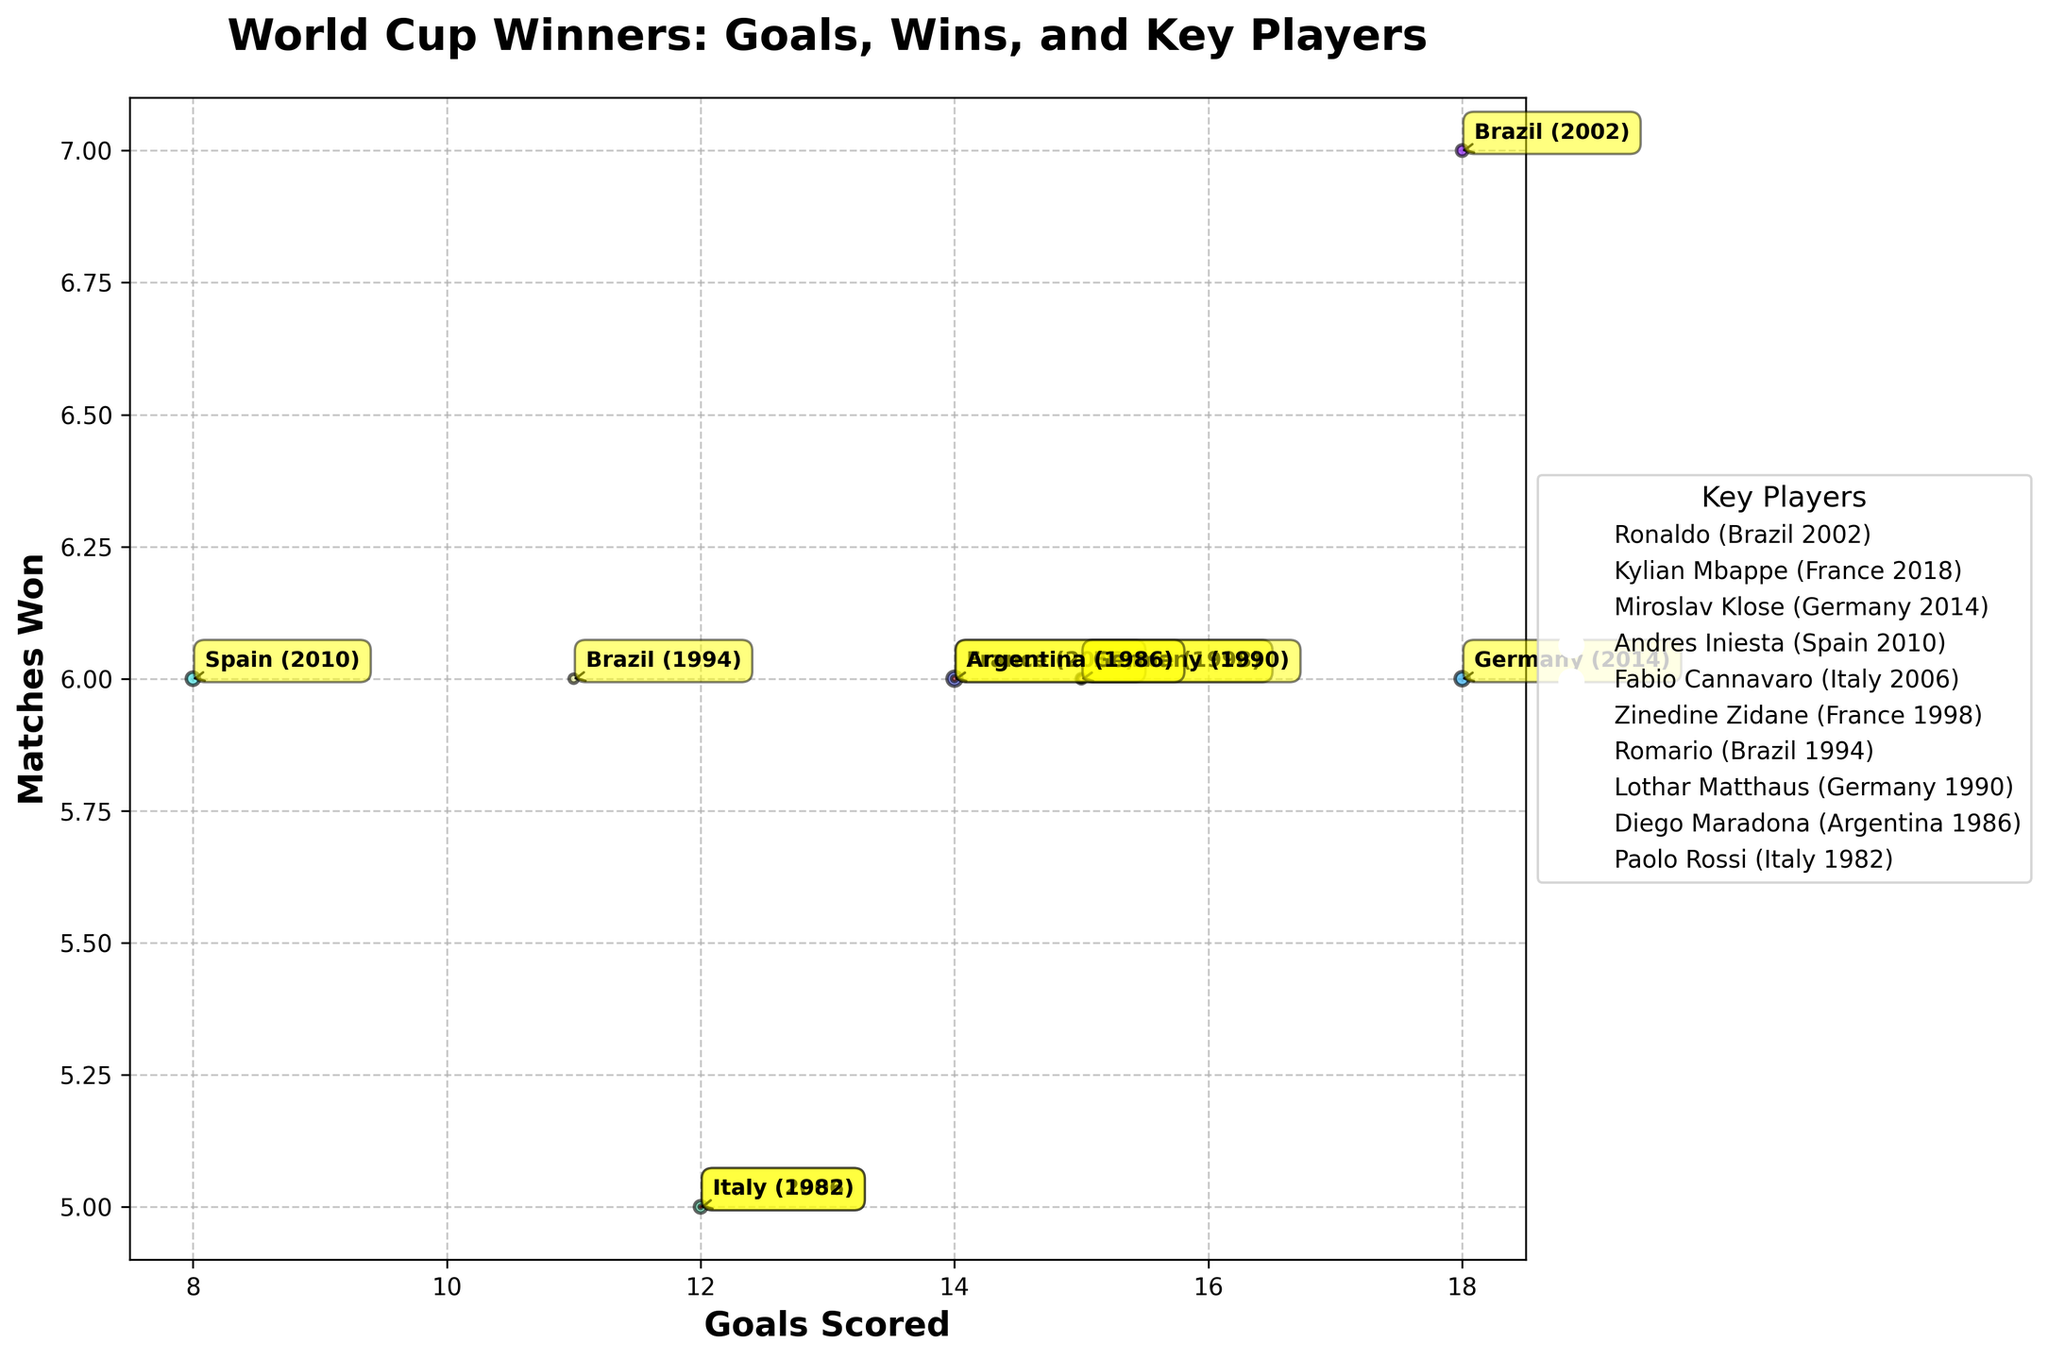What's the title of the figure? The title of the figure is positioned above the main bubble chart and provides context for what the chart represents.
Answer: World Cup Winners: Goals, Wins, and Key Players How many countries have won the World Cup and are displayed on the chart? Each bubble represents a different country that has won the World Cup in a specific year. By counting the bubbles, we can determine the number of countries displayed.
Answer: 10 Which country scored the most goals in a single tournament, and how many did they score? Look for the bubble positioned furthest to the right on the x-axis, as this represents the highest number of goals scored. The annotation next to this bubble will indicate the country and year.
Answer: Brazil, 18 goals Which country won the World Cup in 2002, and who was their key player? Identify the bubble with the annotation indicating the year 2002. The annotation also lists the country and the key player.
Answer: Brazil, Ronaldo How many goals did the winning team score in the 2014 World Cup, and which country won? Find the bubble labeled with the year 2014 and note the position on the x-axis which represents goals scored, as well as the country name from the annotation.
Answer: 18 goals, Germany Which country has the largest bubble and what does it signify? The size of the bubble is determined by the difference between the year the World Cup was won and 1980. Thus, the largest bubble will correspond to the most recent win.
Answer: France (2018) How many matches did the winning team of the 2010 World Cup win? Look at the bubble labeled with the year 2010. Check its position on the y-axis to determine the number of matches won.
Answer: 6 matches Which country won two World Cups shown in the chart, and in which years? Look for the country that has annotations for two different years. This can be quickly determined by identifying repeated country labels.
Answer: Brazil, 1994 and 2002 Between Germany and Argentina, which country won the World Cup in a year closer to the present? Compare the years next to the bubbles for Germany and Argentina and determine which is more recent.
Answer: Germany (2014) What does the color variation of the bubbles represent? The color variation in the bubbles represents different countries' data points, achieved through a color map that assigns unique colors to each entry.
Answer: Different countries 